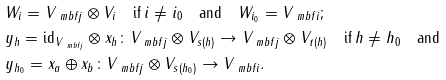Convert formula to latex. <formula><loc_0><loc_0><loc_500><loc_500>& W _ { i } = V _ { \ m b f j } \otimes V _ { i } \quad \text {if} \, i \neq i _ { 0 } \quad \text {and} \quad W _ { i _ { 0 } } = V _ { \ m b f i } ; \\ & y _ { h } = \text {id} _ { V _ { \ m b f j } } \otimes x _ { h } \colon V _ { \ m b f j } \otimes V _ { s ( h ) } \to V _ { \ m b f j } \otimes V _ { t ( h ) } \quad \text {if} \, h \neq h _ { 0 } \quad \text {and} \\ & y _ { h _ { 0 } } = x _ { a } \oplus x _ { b } \colon V _ { \ m b f j } \otimes V _ { s ( h _ { 0 } ) } \to V _ { \ m b f i } .</formula> 